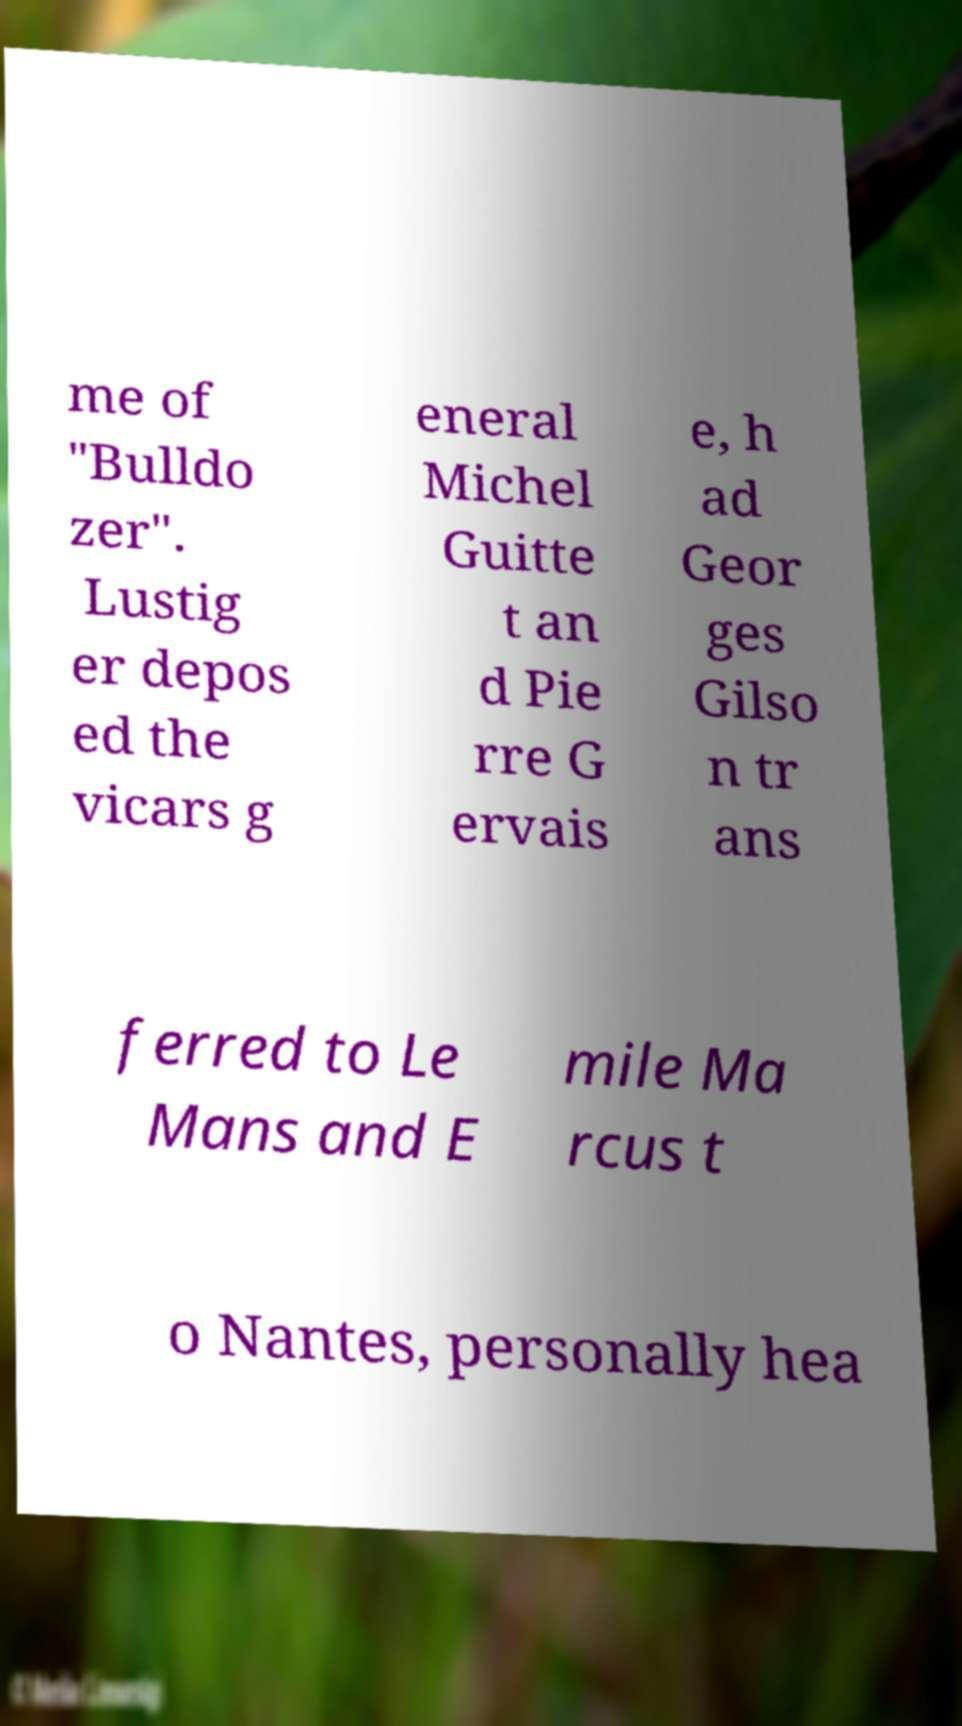I need the written content from this picture converted into text. Can you do that? me of "Bulldo zer". Lustig er depos ed the vicars g eneral Michel Guitte t an d Pie rre G ervais e, h ad Geor ges Gilso n tr ans ferred to Le Mans and E mile Ma rcus t o Nantes, personally hea 